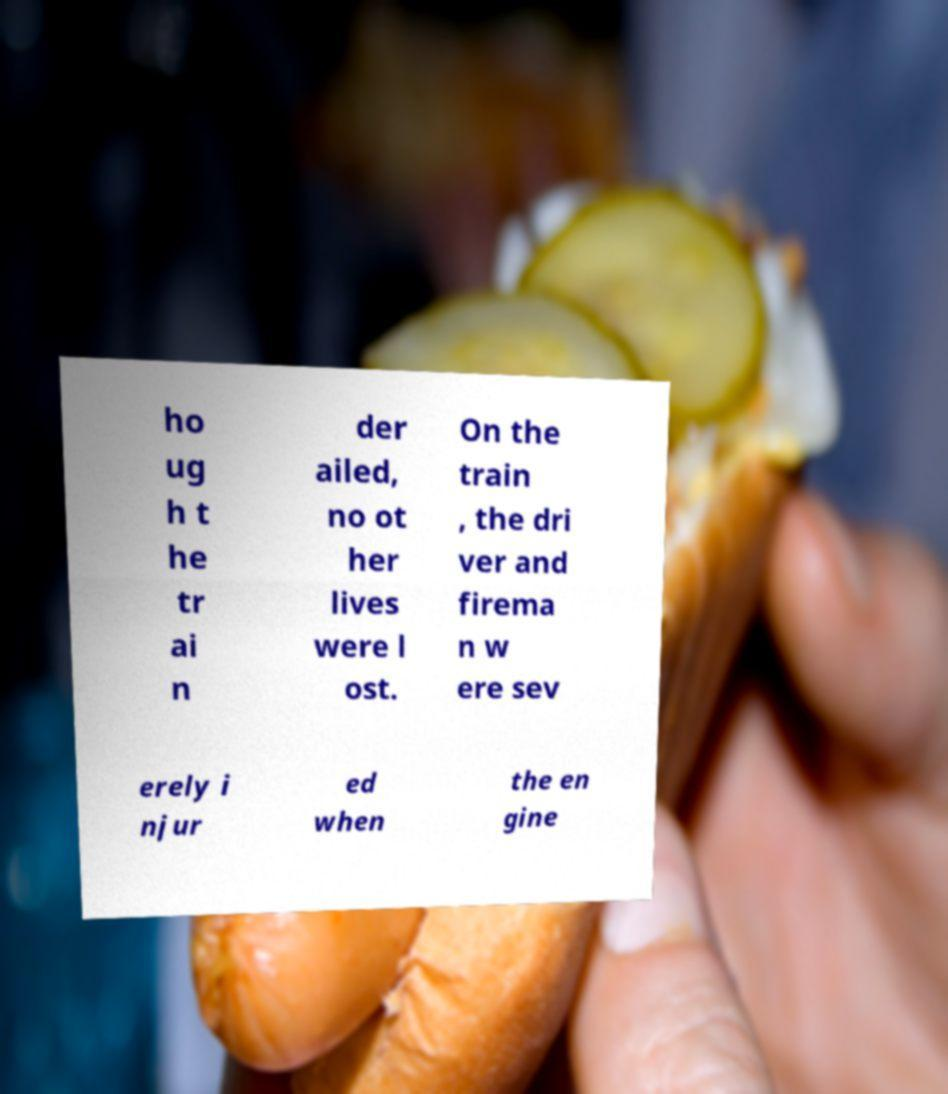There's text embedded in this image that I need extracted. Can you transcribe it verbatim? ho ug h t he tr ai n der ailed, no ot her lives were l ost. On the train , the dri ver and firema n w ere sev erely i njur ed when the en gine 